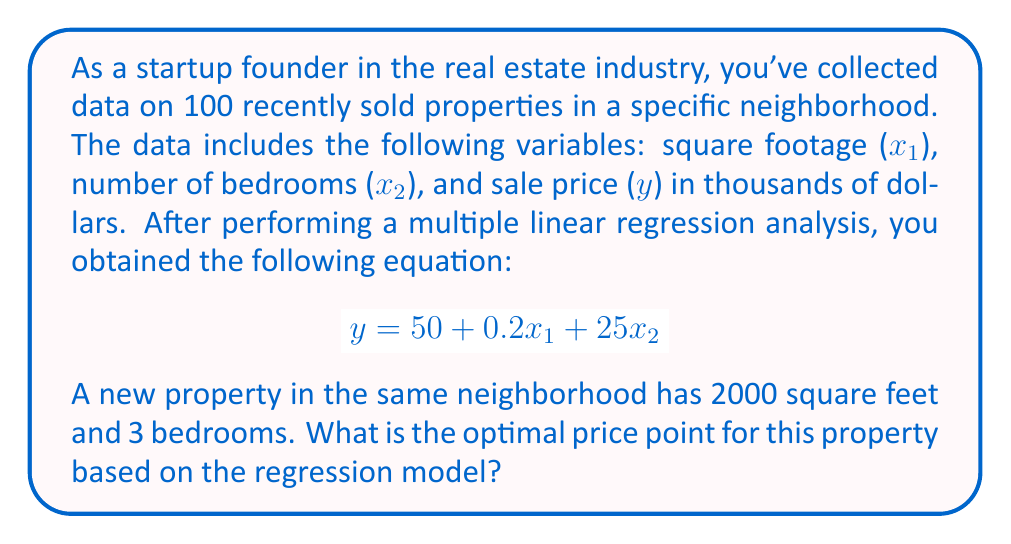What is the answer to this math problem? To determine the optimal price point for the new property using the given regression model, we need to follow these steps:

1. Identify the regression equation:
   The multiple linear regression equation is given as:
   $$y = 50 + 0.2x_1 + 25x_2$$
   Where:
   $y$ is the predicted sale price in thousands of dollars
   $x_1$ is the square footage
   $x_2$ is the number of bedrooms

2. Identify the values for the new property:
   $x_1 = 2000$ (square feet)
   $x_2 = 3$ (bedrooms)

3. Substitute these values into the regression equation:
   $$y = 50 + 0.2(2000) + 25(3)$$

4. Calculate the predicted price:
   $$y = 50 + 400 + 75$$
   $$y = 525$$

5. Interpret the result:
   Since $y$ is in thousands of dollars, we need to multiply the result by 1000 to get the actual price in dollars.

   $525 * 1000 = $525,000$

Therefore, based on the regression model, the optimal price point for the new property with 2000 square feet and 3 bedrooms is $525,000.
Answer: $525,000 